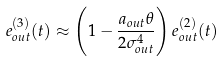<formula> <loc_0><loc_0><loc_500><loc_500>e _ { o u t } ^ { ( 3 ) } ( t ) \approx \left ( 1 - \frac { a _ { o u t } \theta } { 2 \sigma _ { o u t } ^ { 4 } } \right ) e _ { o u t } ^ { ( 2 ) } ( t )</formula> 